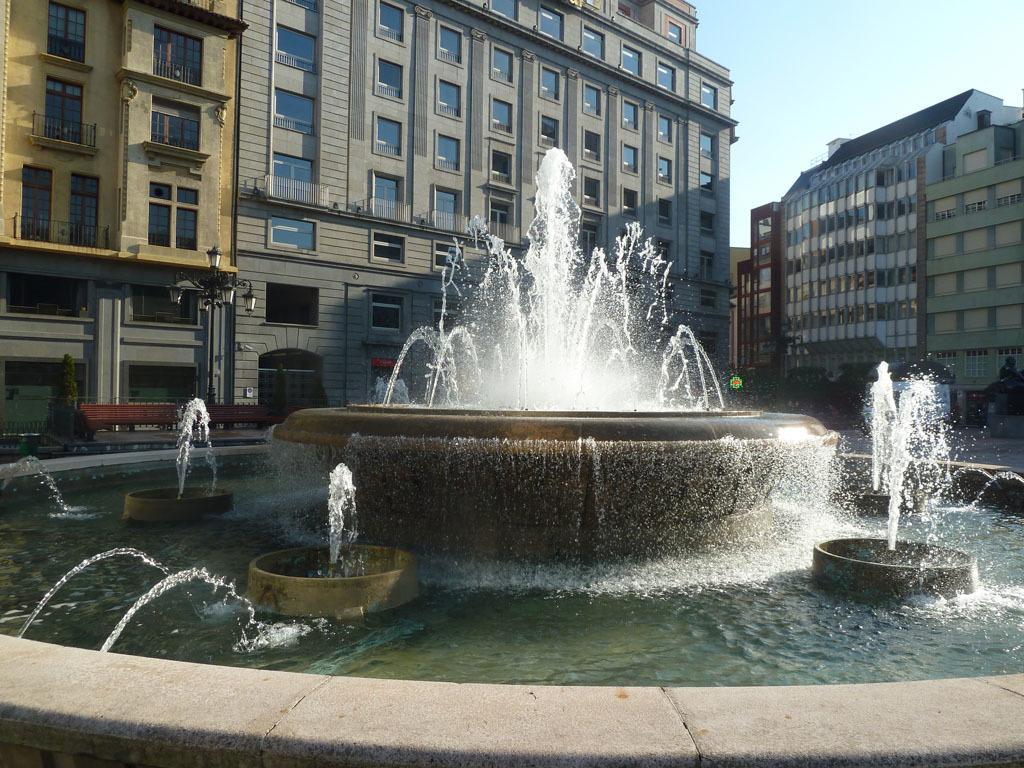Could you give a brief overview of what you see in this image? In this image in the center there is a water fountain. In the background there are buildings and there is a light pole. 